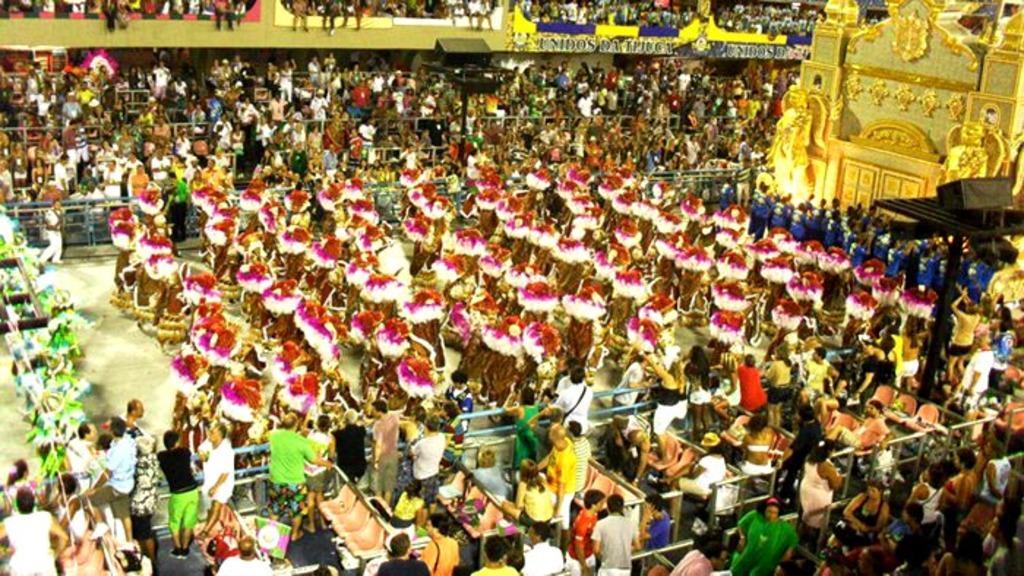How would you summarize this image in a sentence or two? In the image there are many people with costumes. There are many people standing behind the fencing and also there are chairs. At the top of the image there is a wall with name board. And also there are black poles with speakers. There is an artificial wall with decorations, sculptures and arch. 